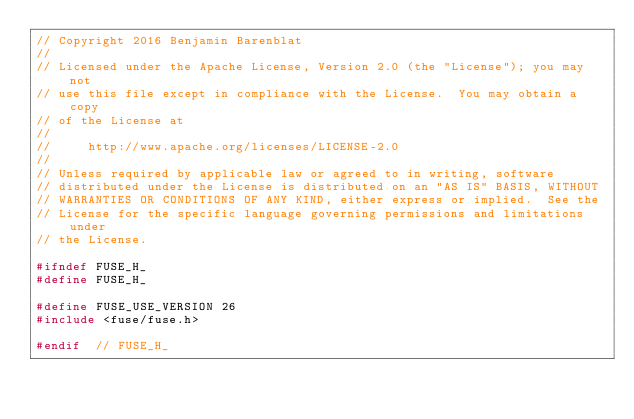Convert code to text. <code><loc_0><loc_0><loc_500><loc_500><_C_>// Copyright 2016 Benjamin Barenblat
//
// Licensed under the Apache License, Version 2.0 (the "License"); you may not
// use this file except in compliance with the License.  You may obtain a copy
// of the License at
//
//     http://www.apache.org/licenses/LICENSE-2.0
//
// Unless required by applicable law or agreed to in writing, software
// distributed under the License is distributed on an "AS IS" BASIS, WITHOUT
// WARRANTIES OR CONDITIONS OF ANY KIND, either express or implied.  See the
// License for the specific language governing permissions and limitations under
// the License.

#ifndef FUSE_H_
#define FUSE_H_

#define FUSE_USE_VERSION 26
#include <fuse/fuse.h>

#endif  // FUSE_H_
</code> 